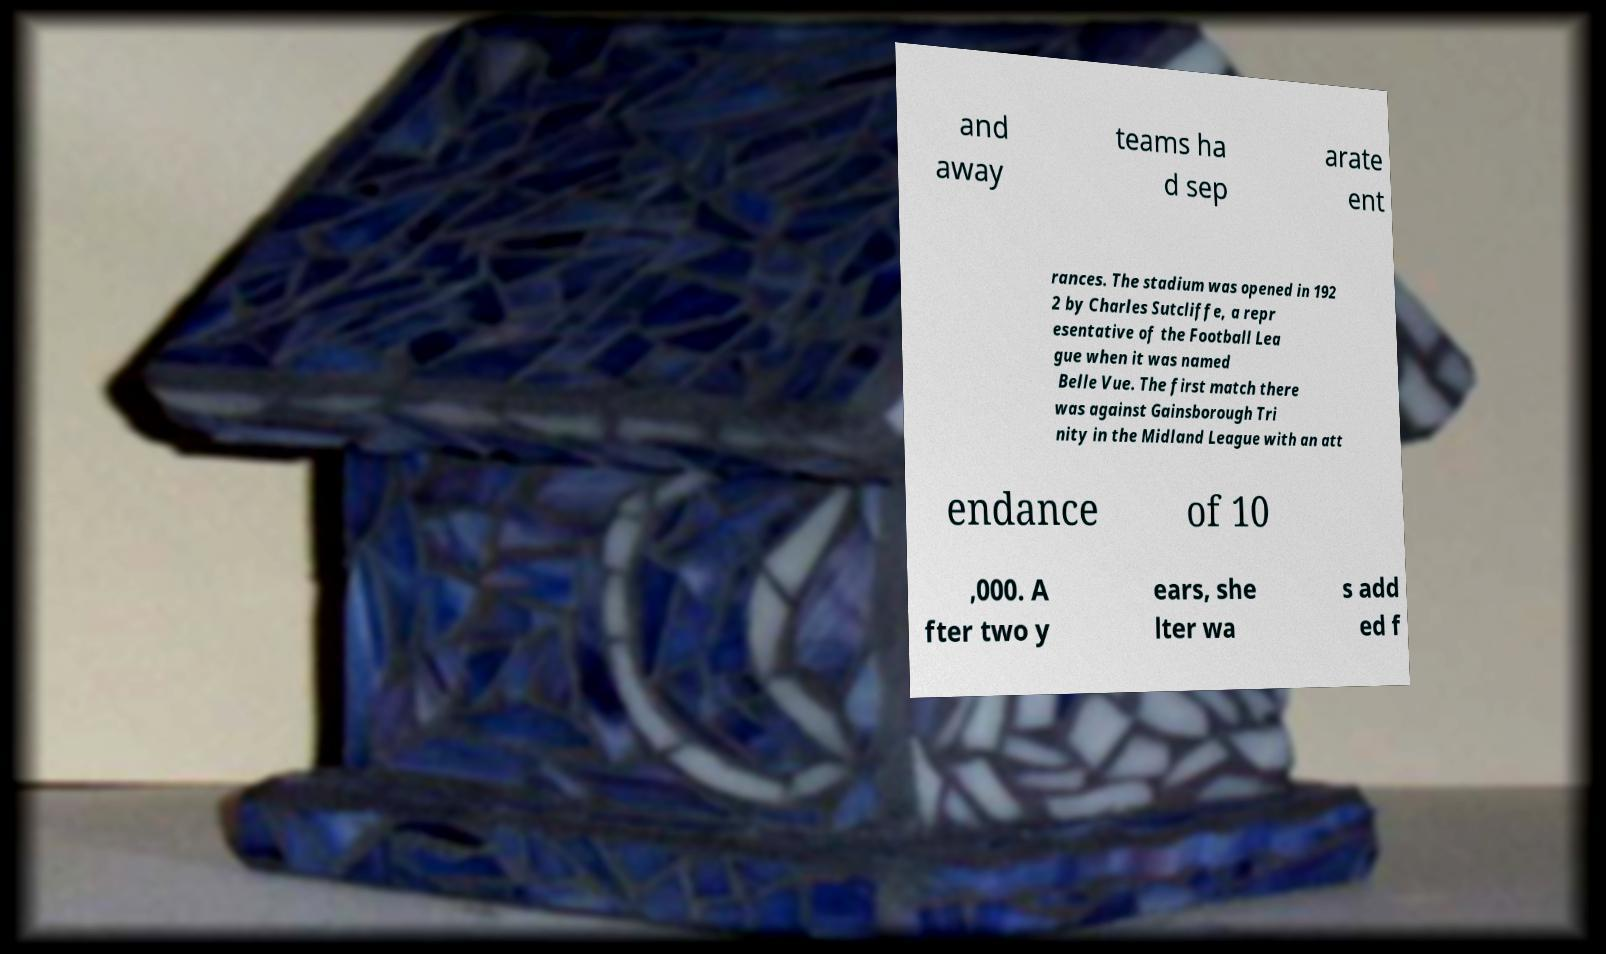Please read and relay the text visible in this image. What does it say? and away teams ha d sep arate ent rances. The stadium was opened in 192 2 by Charles Sutcliffe, a repr esentative of the Football Lea gue when it was named Belle Vue. The first match there was against Gainsborough Tri nity in the Midland League with an att endance of 10 ,000. A fter two y ears, she lter wa s add ed f 